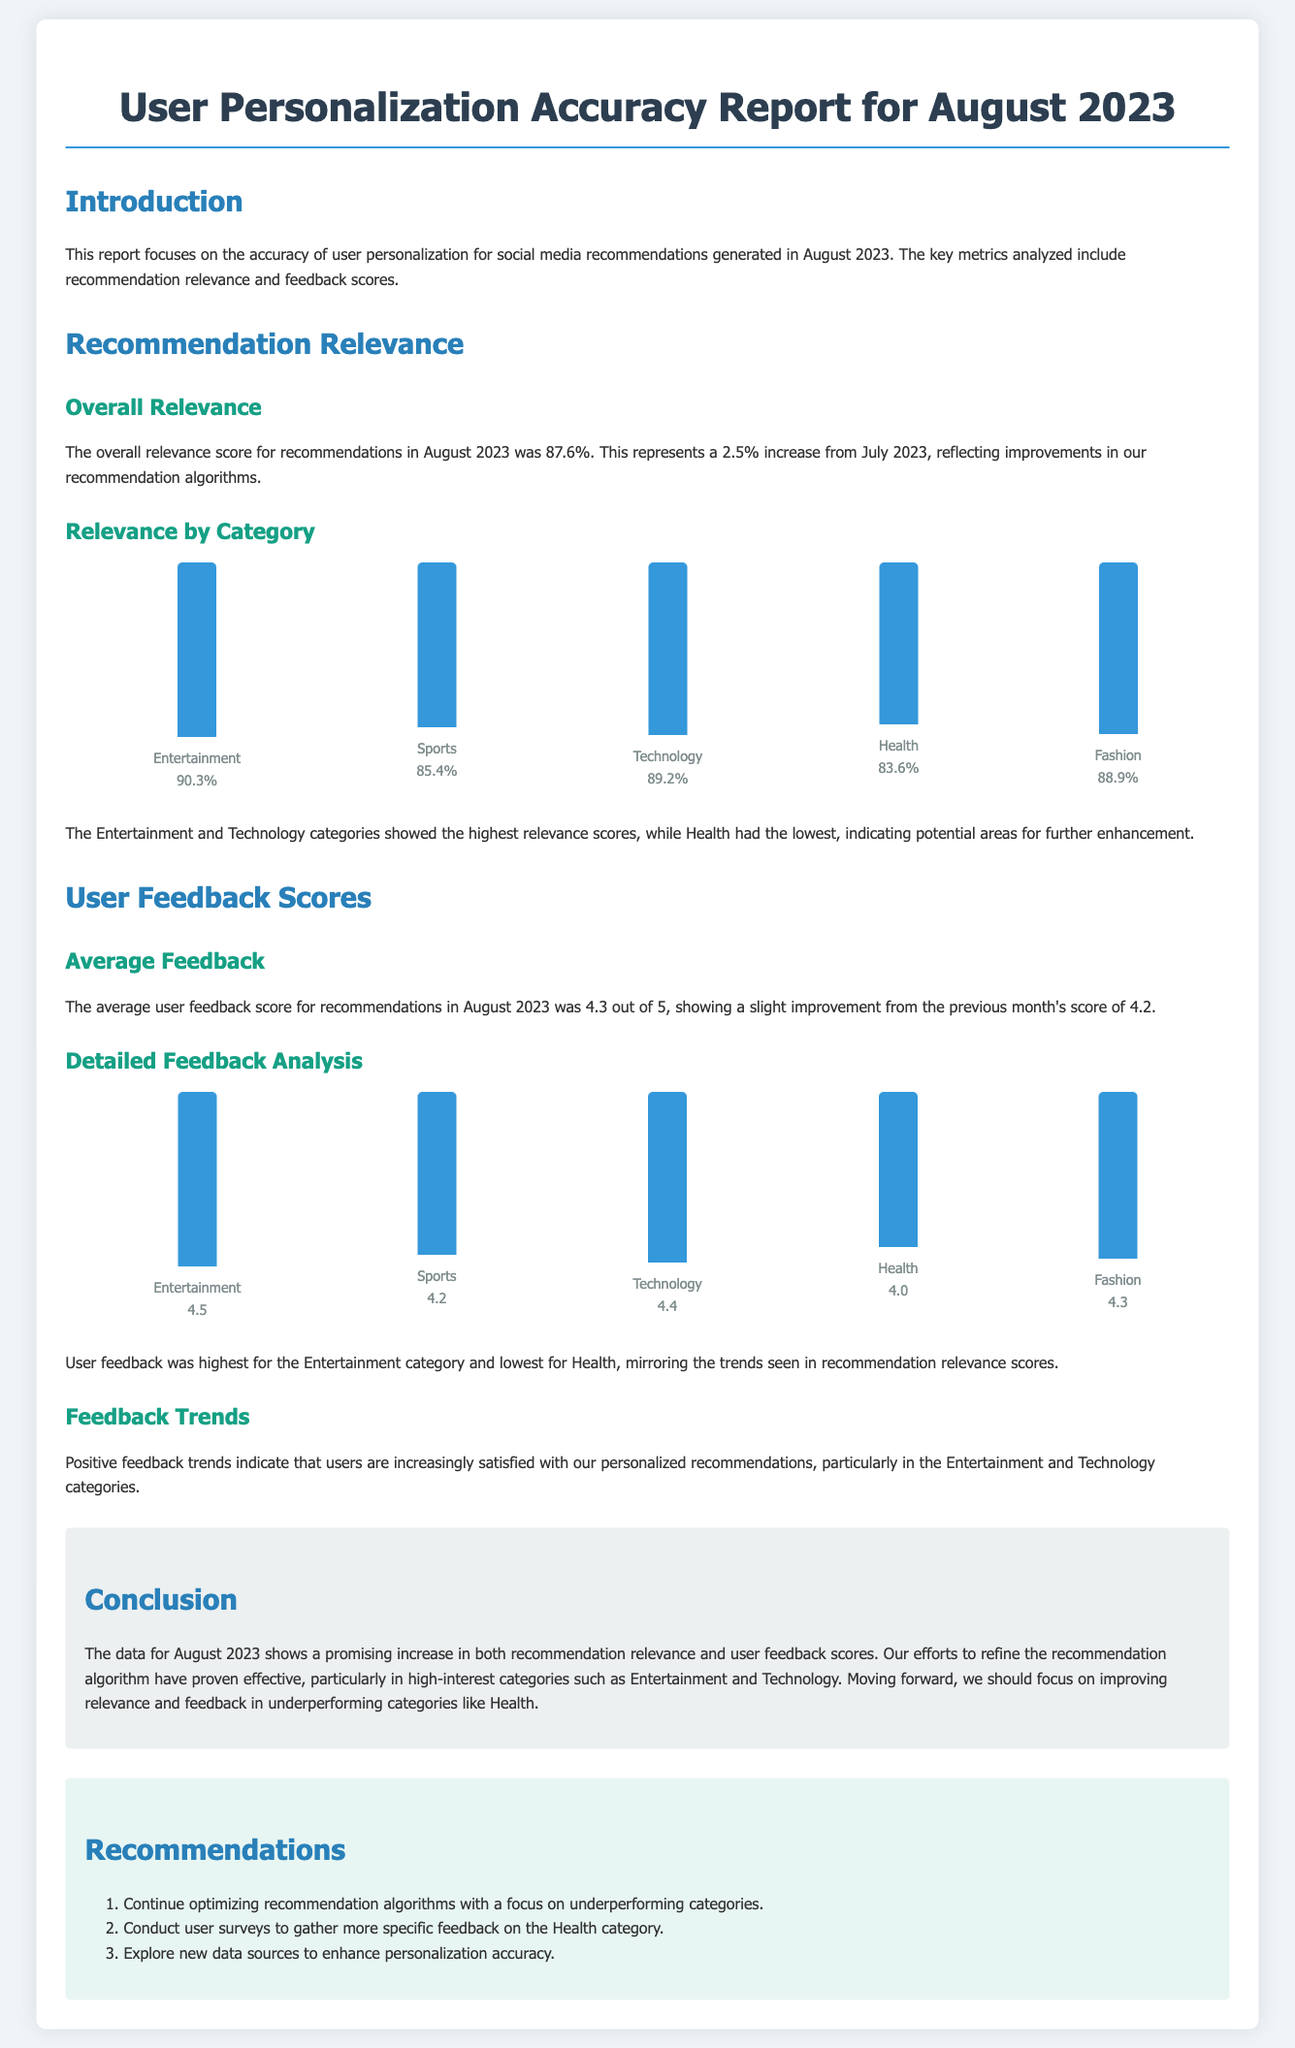what was the overall relevance score for August 2023? The overall relevance score for recommendations in August 2023 was highlighted in the document and is 87.6%.
Answer: 87.6% what category had the highest relevance score? The category with the highest relevance score is mentioned in the report and is Entertainment with a score of 90.3%.
Answer: Entertainment what was the average user feedback score for August 2023? The average user feedback score is explicitly stated in the document and is 4.3 out of 5.
Answer: 4.3 which category received the lowest feedback score? The category with the lowest feedback score is identified in the document and is Health with a score of 4.0.
Answer: Health how much did the overall relevance score increase from July 2023? The report states a specific increase in the overall relevance score from July 2023, which is 2.5%.
Answer: 2.5% what are the recommendations for improving user personalization? The recommendations are presented in an ordered list in the document, focusing on optimization and user feedback.
Answer: Optimize recommendation algorithms, conduct user surveys, explore new data sources what trend was observed in user feedback? The document discusses the trend in user feedback, which indicates an increase in user satisfaction.
Answer: Increased satisfaction which two categories exhibited the highest user feedback scores? The categories with the highest user feedback scores are specified in the report as Entertainment and Technology.
Answer: Entertainment and Technology what was the relevance score for the Sports category? The relevance score for the Sports category is directly provided in the document as 85.4%.
Answer: 85.4% 